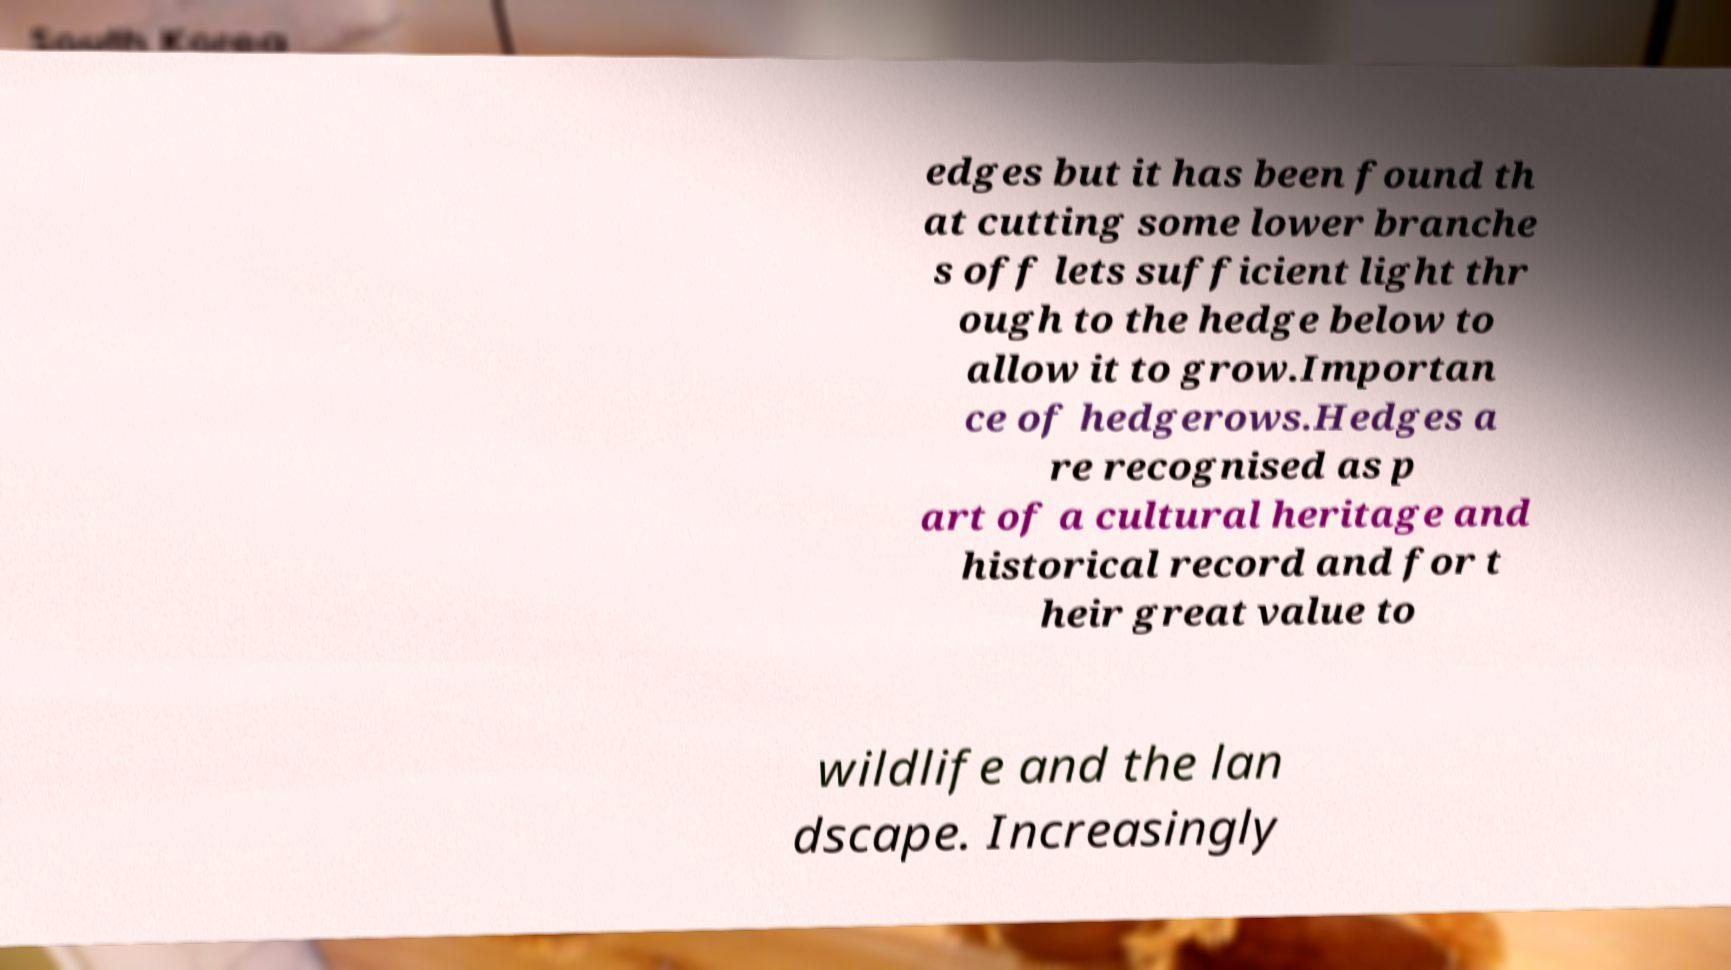Please read and relay the text visible in this image. What does it say? edges but it has been found th at cutting some lower branche s off lets sufficient light thr ough to the hedge below to allow it to grow.Importan ce of hedgerows.Hedges a re recognised as p art of a cultural heritage and historical record and for t heir great value to wildlife and the lan dscape. Increasingly 